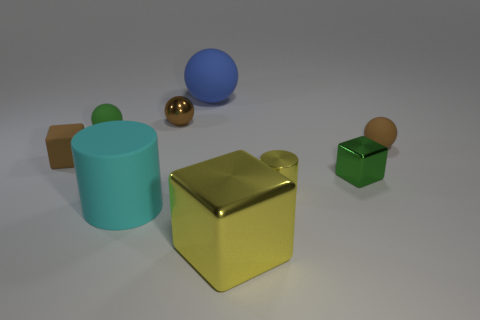Subtract all yellow cylinders. How many brown balls are left? 2 Add 1 yellow metal objects. How many objects exist? 10 Subtract all matte spheres. How many spheres are left? 1 Subtract all green balls. How many balls are left? 3 Subtract all red balls. Subtract all yellow cubes. How many balls are left? 4 Subtract all cylinders. How many objects are left? 7 Subtract all tiny rubber balls. Subtract all tiny blue rubber blocks. How many objects are left? 7 Add 6 balls. How many balls are left? 10 Add 4 big yellow metallic objects. How many big yellow metallic objects exist? 5 Subtract 1 brown cubes. How many objects are left? 8 